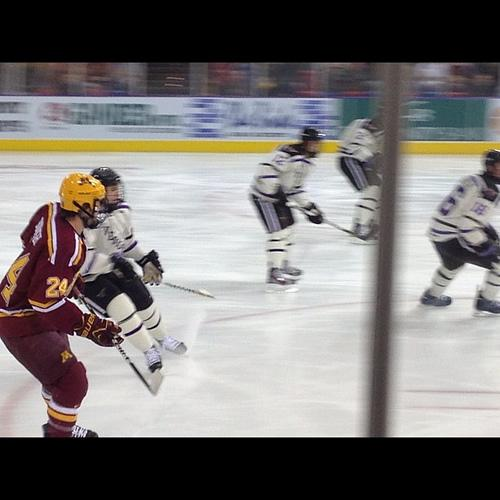What does the black and white hockey stick look like, and what is it doing in the scene? The black and white hockey stick is being held by a player and is lifted in the air. Explain what the hockey player in the white and black uniform is doing. The hockey player in the white and black uniform is skating on the ice. What type of protective gear is worn by the hockey player in the white and black uniform? The player is wearing white shin guards with black stripes. What is the number written on the first hockey player's jersey? The number 24 is written on the player's jersey. Describe the black and white hockey uniform, including any special markings or details. The uniform consists of black skates, black stripes on white socks, a white laces on black ice skates, and a blue number 12 on the white jersey. What is the color and type of the helmet worn by the hockey player in the white and blue uniform? The hockey player is wearing a black hockey helmet. Describe the ice rink in the image including any details around its edge. The ice rink is white with a yellow stripe along the bottom and green lettering on a white backboard. What type of helmet is worn by the player with a yellow helmet, and what is unique about the design? The player is wearing a yellow hockey helmet with black straps and a cage. How many total hockey players can be seen in the image, and what are the members of the opposite teams wearing? There are two hockey players visible, with one wearing marron and gold, and the other wearing white and black. Identify the color scheme of the outfit worn by the first hockey player mentioned in the image. The hockey player is wearing a marron and gold uniform. 